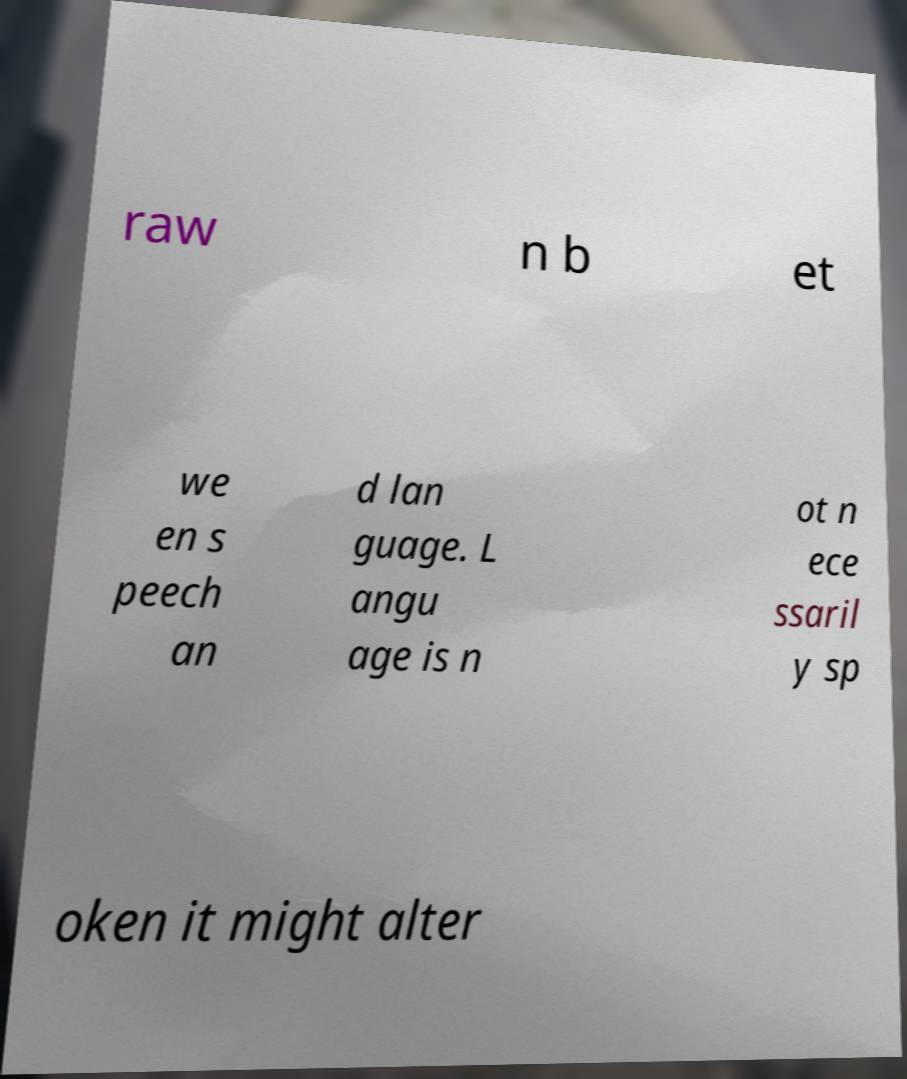What messages or text are displayed in this image? I need them in a readable, typed format. raw n b et we en s peech an d lan guage. L angu age is n ot n ece ssaril y sp oken it might alter 